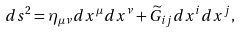Convert formula to latex. <formula><loc_0><loc_0><loc_500><loc_500>d s ^ { 2 } = \eta _ { \mu \nu } d x ^ { \mu } d x ^ { \nu } + { \widetilde { G } } _ { i j } d x ^ { i } d x ^ { j } ,</formula> 